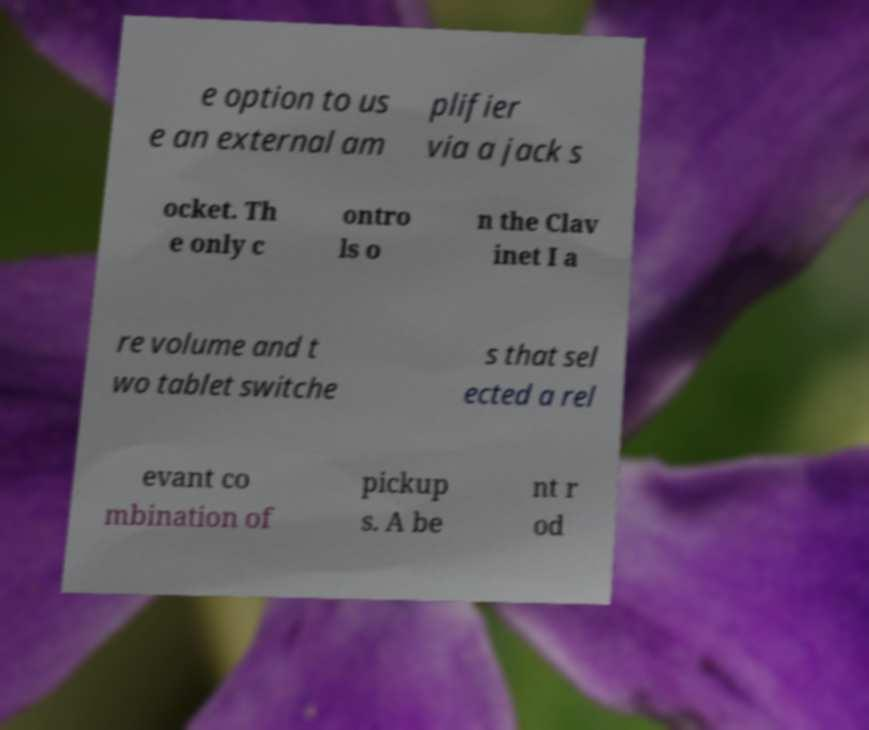Could you extract and type out the text from this image? e option to us e an external am plifier via a jack s ocket. Th e only c ontro ls o n the Clav inet I a re volume and t wo tablet switche s that sel ected a rel evant co mbination of pickup s. A be nt r od 